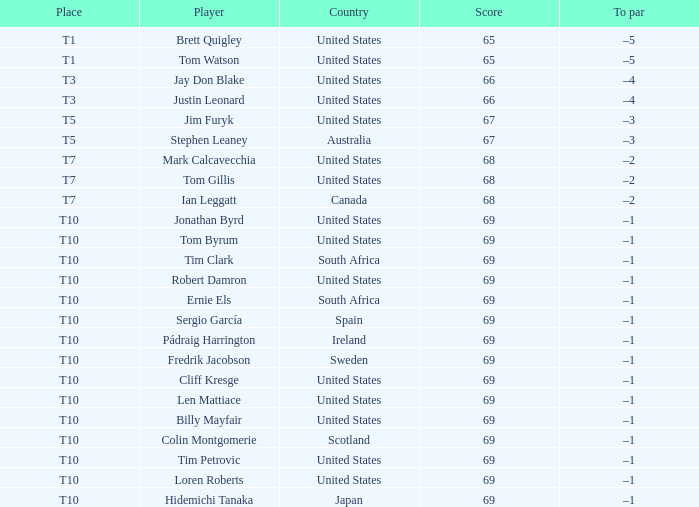Which individual is referred to as the t3 player? Jay Don Blake, Justin Leonard. 